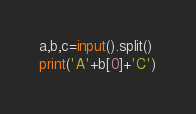Convert code to text. <code><loc_0><loc_0><loc_500><loc_500><_Python_>a,b,c=input().split()
print('A'+b[0]+'C')</code> 